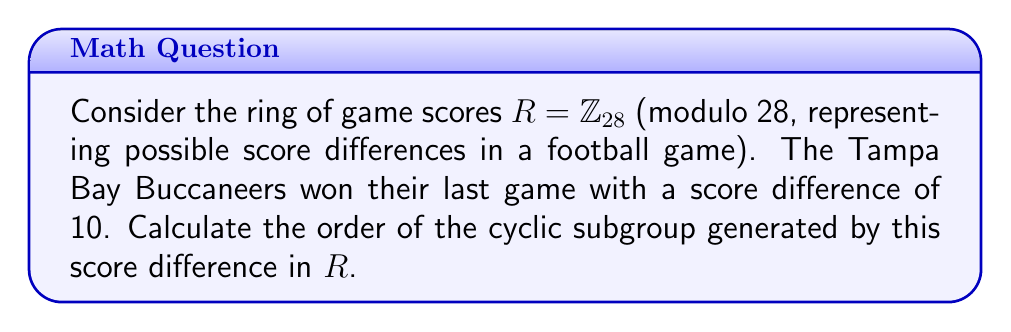Can you solve this math problem? To solve this problem, we need to follow these steps:

1) In the ring $R = \mathbb{Z}_{28}$, we're looking at the cyclic subgroup generated by 10, which we can denote as $\langle 10 \rangle$.

2) The order of this subgroup is the smallest positive integer $n$ such that $10n \equiv 0 \pmod{28}$.

3) We can find this by listing out the multiples of 10 in $\mathbb{Z}_{28}$:

   $10 \cdot 1 \equiv 10 \pmod{28}$
   $10 \cdot 2 \equiv 20 \pmod{28}$
   $10 \cdot 3 \equiv 2 \pmod{28}$
   $10 \cdot 4 \equiv 12 \pmod{28}$
   $10 \cdot 5 \equiv 22 \pmod{28}$
   $10 \cdot 6 \equiv 4 \pmod{28}$
   $10 \cdot 7 \equiv 14 \pmod{28}$
   $10 \cdot 8 \equiv 24 \pmod{28}$
   $10 \cdot 9 \equiv 6 \pmod{28}$
   $10 \cdot 10 \equiv 16 \pmod{28}$
   $10 \cdot 11 \equiv 26 \pmod{28}$
   $10 \cdot 12 \equiv 8 \pmod{28}$
   $10 \cdot 13 \equiv 18 \pmod{28}$
   $10 \cdot 14 \equiv 0 \pmod{28}$

4) We see that $10 \cdot 14 \equiv 0 \pmod{28}$, and this is the smallest positive integer with this property.

5) Therefore, the order of the cyclic subgroup $\langle 10 \rangle$ in $\mathbb{Z}_{28}$ is 14.

This result shows that if the Buccaneers continue to win by a score difference of 10, the cycle of score differences in $\mathbb{Z}_{28}$ will repeat after 14 games.
Answer: The order of the cyclic subgroup generated by 10 in $\mathbb{Z}_{28}$ is 14. 